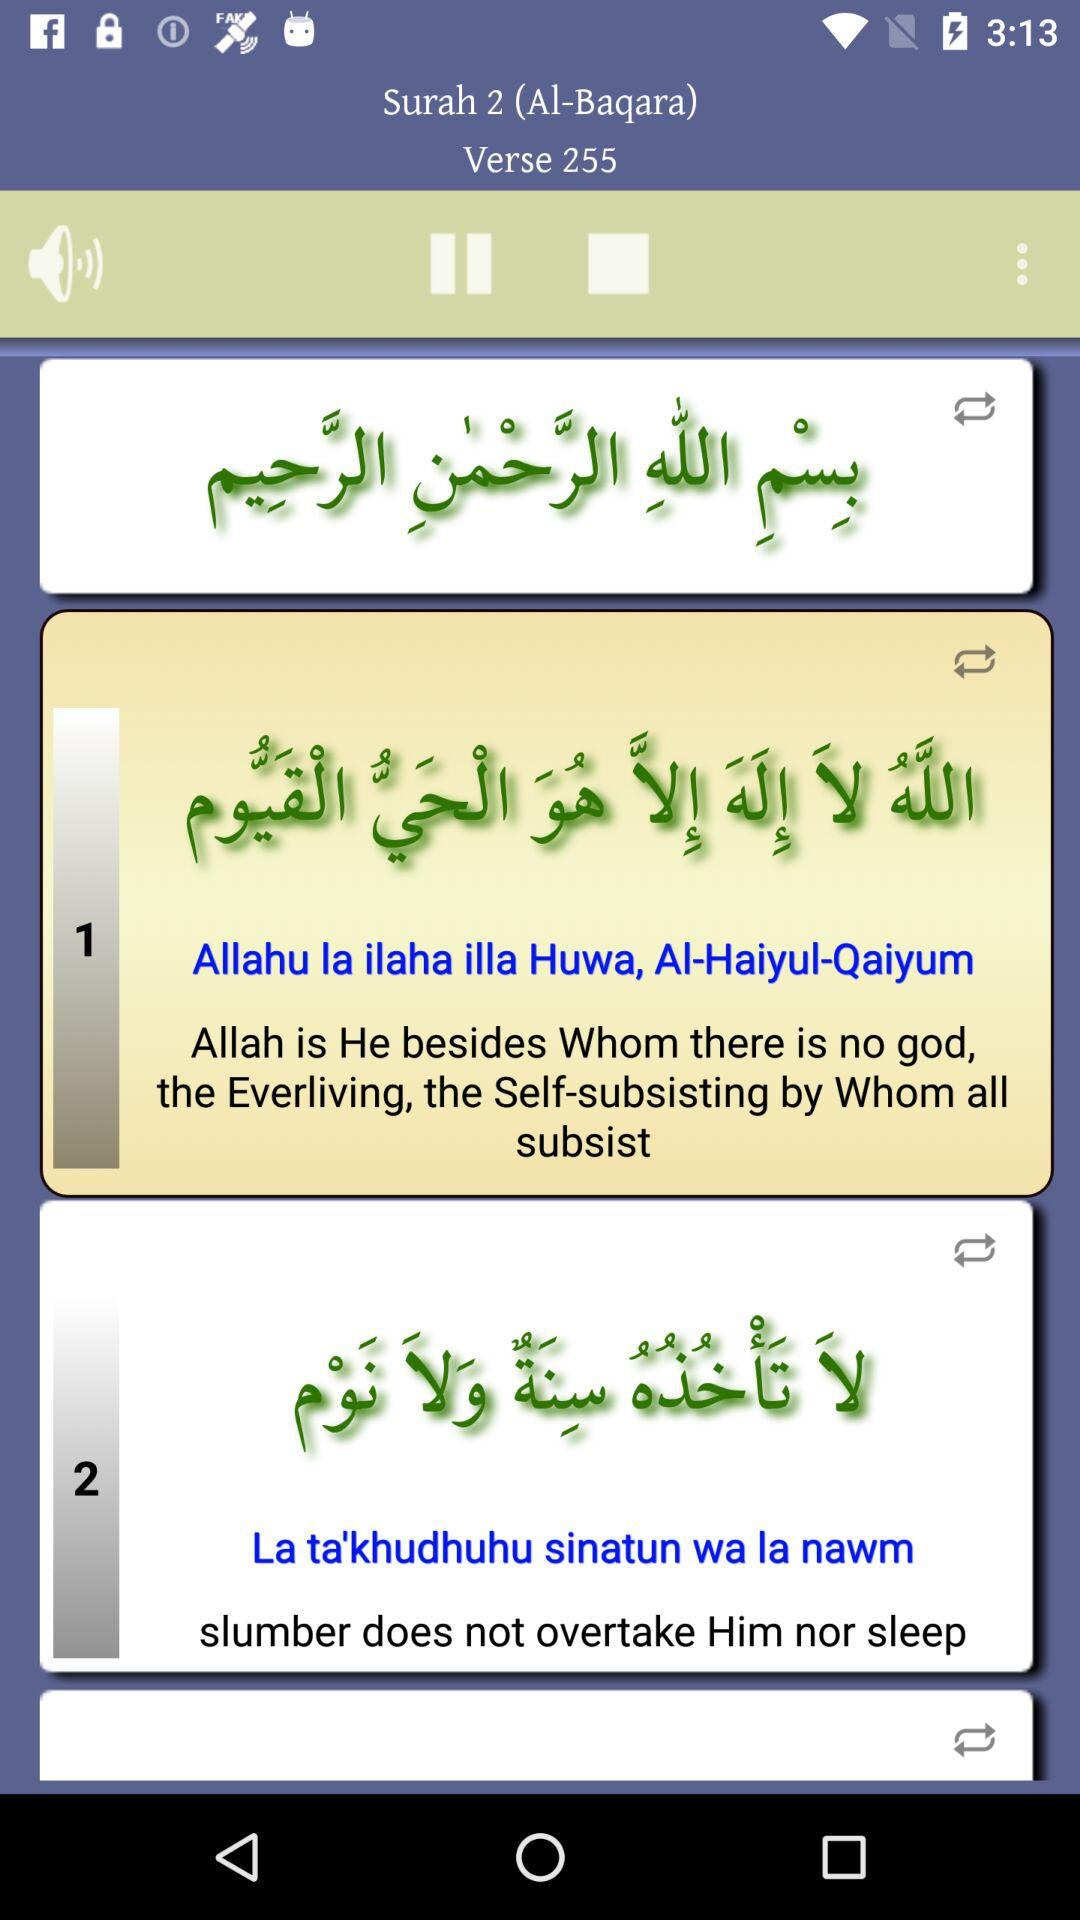What's the verse number? The verse number is 255. 